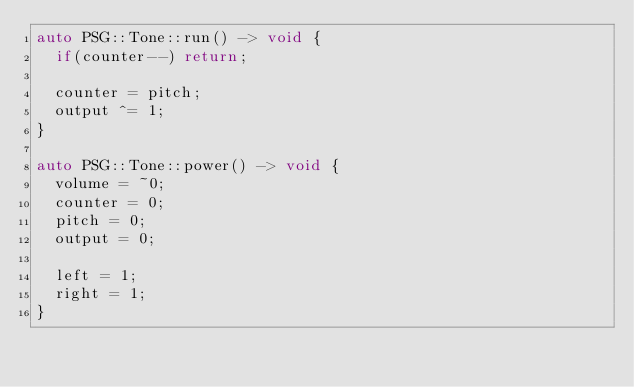<code> <loc_0><loc_0><loc_500><loc_500><_C++_>auto PSG::Tone::run() -> void {
  if(counter--) return;

  counter = pitch;
  output ^= 1;
}

auto PSG::Tone::power() -> void {
  volume = ~0;
  counter = 0;
  pitch = 0;
  output = 0;

  left = 1;
  right = 1;
}
</code> 